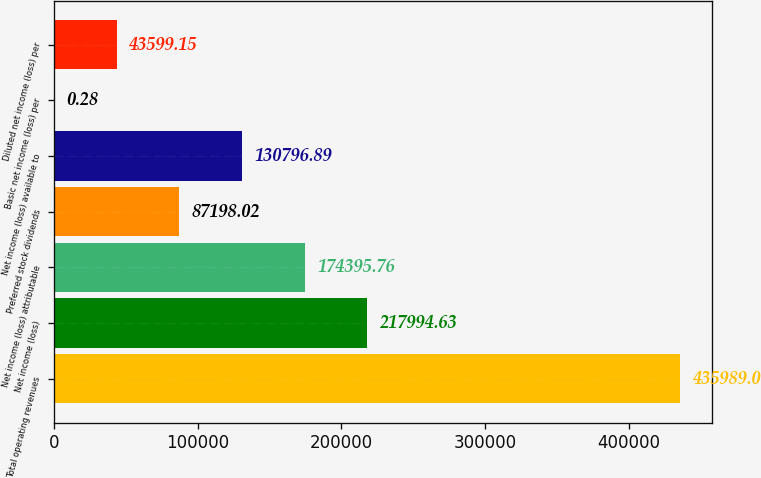Convert chart. <chart><loc_0><loc_0><loc_500><loc_500><bar_chart><fcel>Total operating revenues<fcel>Net income (loss)<fcel>Net income (loss) attributable<fcel>Preferred stock dividends<fcel>Net income (loss) available to<fcel>Basic net income (loss) per<fcel>Diluted net income (loss) per<nl><fcel>435989<fcel>217995<fcel>174396<fcel>87198<fcel>130797<fcel>0.28<fcel>43599.2<nl></chart> 